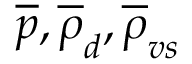Convert formula to latex. <formula><loc_0><loc_0><loc_500><loc_500>\overline { p } , \overline { \rho } _ { d } , \overline { \rho } _ { v s }</formula> 